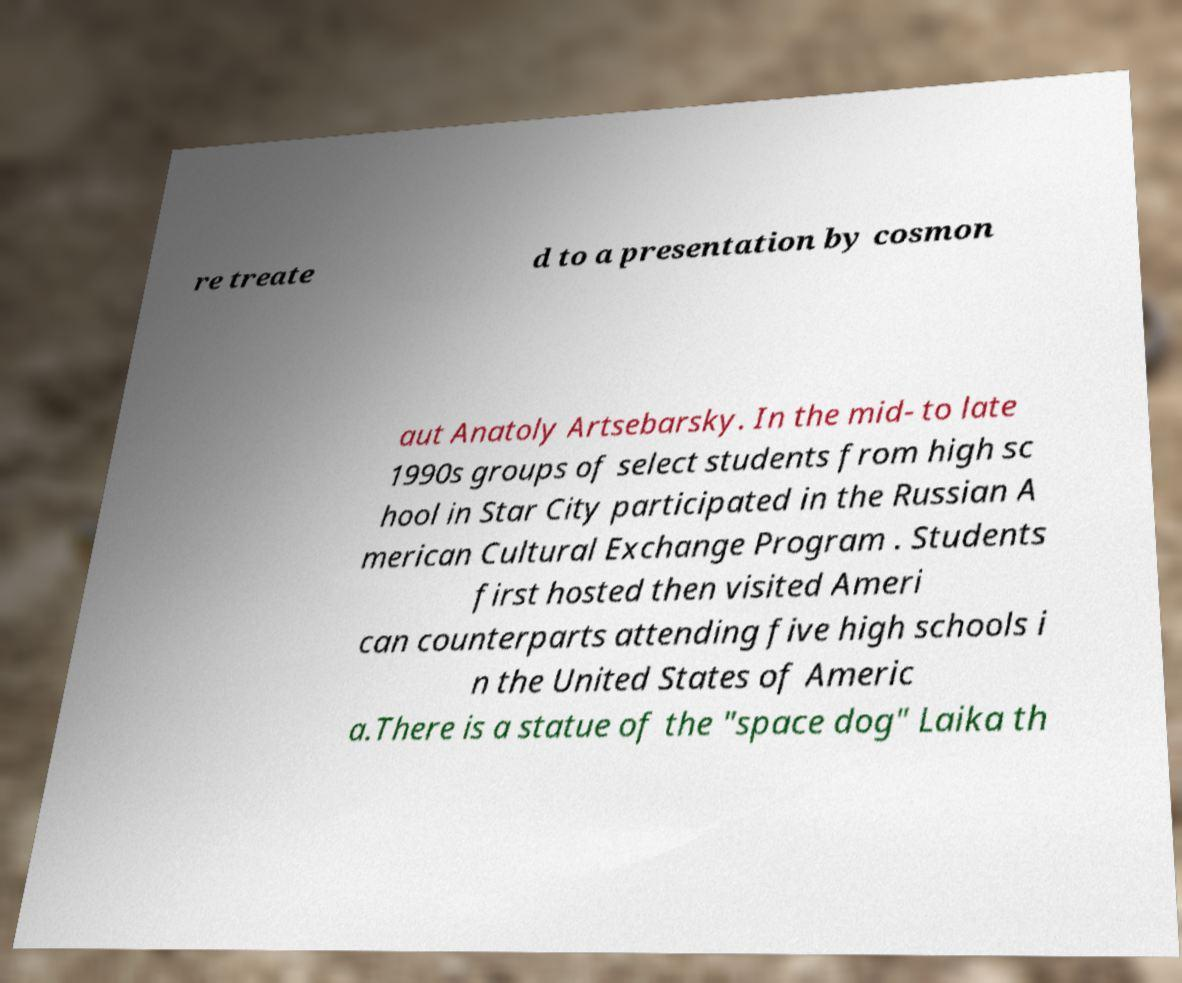What messages or text are displayed in this image? I need them in a readable, typed format. re treate d to a presentation by cosmon aut Anatoly Artsebarsky. In the mid- to late 1990s groups of select students from high sc hool in Star City participated in the Russian A merican Cultural Exchange Program . Students first hosted then visited Ameri can counterparts attending five high schools i n the United States of Americ a.There is a statue of the "space dog" Laika th 